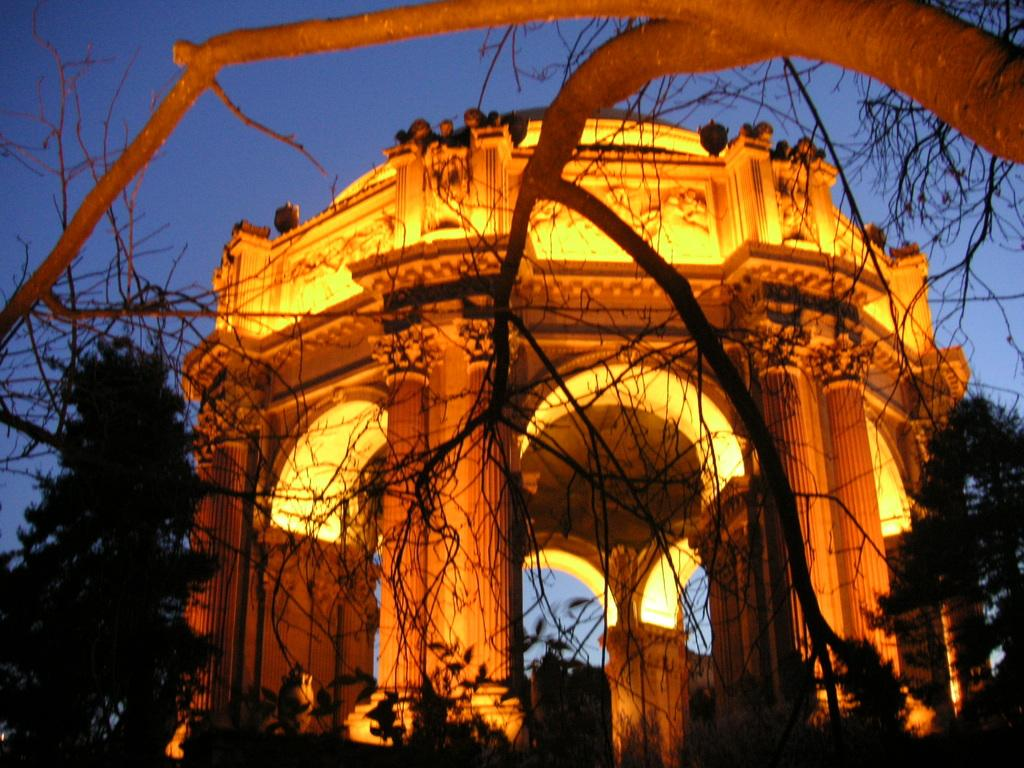What is the main subject of the image? There is a monument in the image. What is the color of the monument? The monument is orange in color. What other elements are present in the image besides the monument? There are trees and the sky visible in the image. How would you describe the sky in the image? The sky appears to be dark in the image. What type of silk is draped over the monument in the image? There is no silk present in the image; the monument is orange in color and stands alone in the scene. 